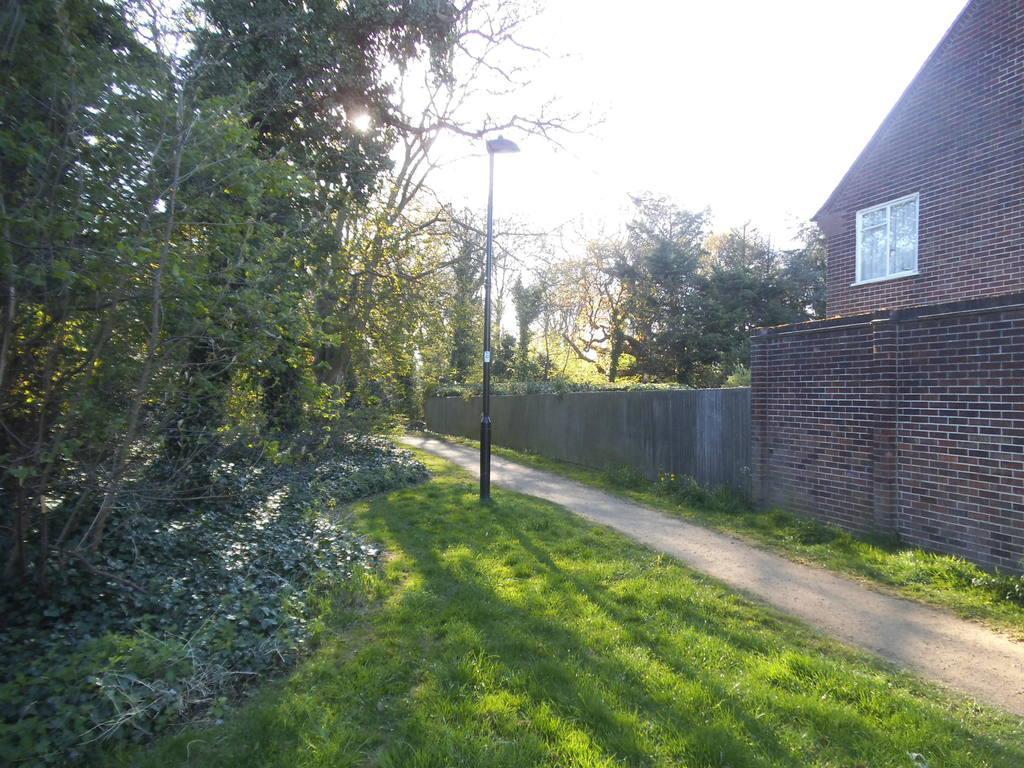In one or two sentences, can you explain what this image depicts? On the left side there are trees. On the ground there are plants and grass. Also there is a light pole. There is a road. On the right side there is wall and a building with brick wall and window. In the background there are trees and sky. 